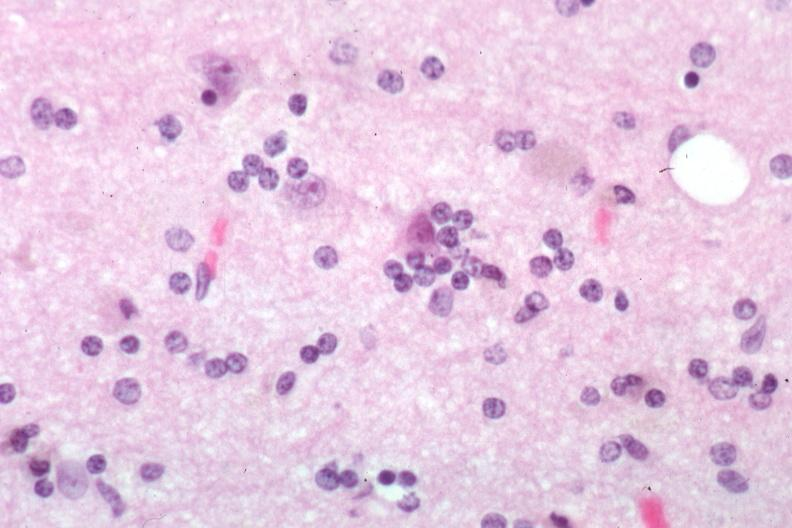s brain present?
Answer the question using a single word or phrase. Yes 